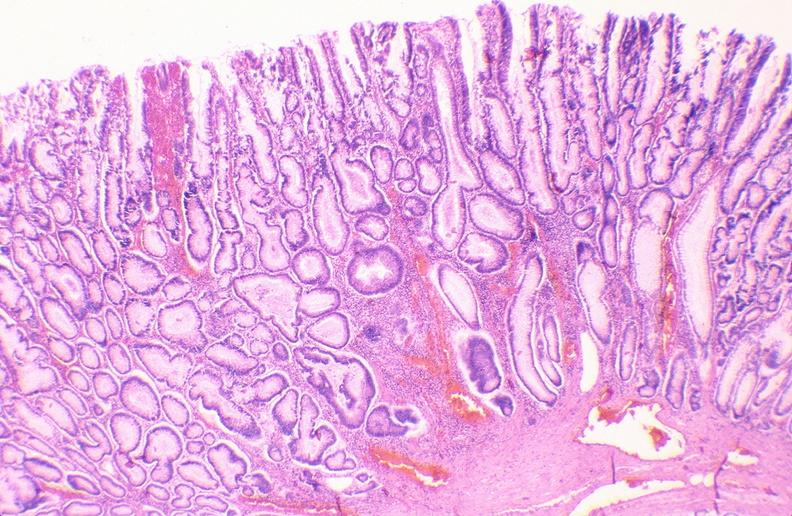s gastrointestinal present?
Answer the question using a single word or phrase. Yes 